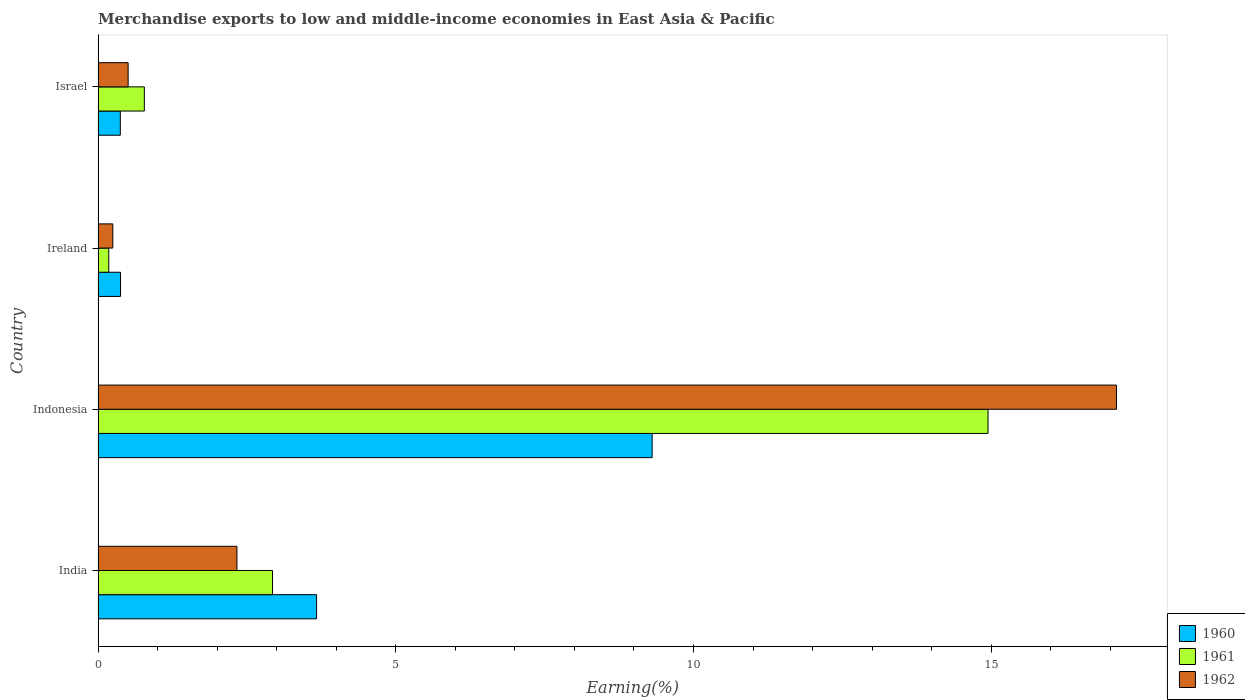Are the number of bars per tick equal to the number of legend labels?
Offer a very short reply. Yes. What is the label of the 2nd group of bars from the top?
Make the answer very short. Ireland. What is the percentage of amount earned from merchandise exports in 1962 in Ireland?
Provide a short and direct response. 0.25. Across all countries, what is the maximum percentage of amount earned from merchandise exports in 1961?
Make the answer very short. 14.95. Across all countries, what is the minimum percentage of amount earned from merchandise exports in 1961?
Provide a short and direct response. 0.18. In which country was the percentage of amount earned from merchandise exports in 1960 maximum?
Ensure brevity in your answer.  Indonesia. What is the total percentage of amount earned from merchandise exports in 1962 in the graph?
Your response must be concise. 20.19. What is the difference between the percentage of amount earned from merchandise exports in 1961 in Indonesia and that in Ireland?
Your answer should be compact. 14.77. What is the difference between the percentage of amount earned from merchandise exports in 1960 in Israel and the percentage of amount earned from merchandise exports in 1961 in India?
Your answer should be compact. -2.56. What is the average percentage of amount earned from merchandise exports in 1960 per country?
Offer a very short reply. 3.43. What is the difference between the percentage of amount earned from merchandise exports in 1962 and percentage of amount earned from merchandise exports in 1961 in India?
Provide a succinct answer. -0.6. In how many countries, is the percentage of amount earned from merchandise exports in 1961 greater than 11 %?
Your answer should be very brief. 1. What is the ratio of the percentage of amount earned from merchandise exports in 1960 in India to that in Israel?
Offer a very short reply. 9.84. Is the difference between the percentage of amount earned from merchandise exports in 1962 in India and Israel greater than the difference between the percentage of amount earned from merchandise exports in 1961 in India and Israel?
Make the answer very short. No. What is the difference between the highest and the second highest percentage of amount earned from merchandise exports in 1961?
Offer a terse response. 12.02. What is the difference between the highest and the lowest percentage of amount earned from merchandise exports in 1960?
Make the answer very short. 8.93. Is it the case that in every country, the sum of the percentage of amount earned from merchandise exports in 1962 and percentage of amount earned from merchandise exports in 1960 is greater than the percentage of amount earned from merchandise exports in 1961?
Your answer should be very brief. Yes. How many bars are there?
Provide a succinct answer. 12. Are all the bars in the graph horizontal?
Provide a succinct answer. Yes. How many countries are there in the graph?
Your response must be concise. 4. Does the graph contain any zero values?
Provide a short and direct response. No. Does the graph contain grids?
Provide a short and direct response. No. Where does the legend appear in the graph?
Your response must be concise. Bottom right. How many legend labels are there?
Your answer should be very brief. 3. What is the title of the graph?
Provide a short and direct response. Merchandise exports to low and middle-income economies in East Asia & Pacific. Does "2009" appear as one of the legend labels in the graph?
Your answer should be compact. No. What is the label or title of the X-axis?
Your response must be concise. Earning(%). What is the Earning(%) of 1960 in India?
Offer a terse response. 3.67. What is the Earning(%) of 1961 in India?
Your answer should be very brief. 2.93. What is the Earning(%) of 1962 in India?
Offer a terse response. 2.33. What is the Earning(%) in 1960 in Indonesia?
Offer a very short reply. 9.31. What is the Earning(%) in 1961 in Indonesia?
Provide a succinct answer. 14.95. What is the Earning(%) in 1962 in Indonesia?
Keep it short and to the point. 17.11. What is the Earning(%) in 1960 in Ireland?
Provide a succinct answer. 0.38. What is the Earning(%) of 1961 in Ireland?
Your response must be concise. 0.18. What is the Earning(%) in 1962 in Ireland?
Your answer should be compact. 0.25. What is the Earning(%) of 1960 in Israel?
Keep it short and to the point. 0.37. What is the Earning(%) in 1961 in Israel?
Provide a short and direct response. 0.78. What is the Earning(%) in 1962 in Israel?
Your answer should be compact. 0.5. Across all countries, what is the maximum Earning(%) in 1960?
Give a very brief answer. 9.31. Across all countries, what is the maximum Earning(%) of 1961?
Make the answer very short. 14.95. Across all countries, what is the maximum Earning(%) of 1962?
Your answer should be compact. 17.11. Across all countries, what is the minimum Earning(%) in 1960?
Give a very brief answer. 0.37. Across all countries, what is the minimum Earning(%) of 1961?
Offer a terse response. 0.18. Across all countries, what is the minimum Earning(%) of 1962?
Offer a very short reply. 0.25. What is the total Earning(%) of 1960 in the graph?
Offer a terse response. 13.72. What is the total Earning(%) of 1961 in the graph?
Keep it short and to the point. 18.83. What is the total Earning(%) of 1962 in the graph?
Offer a very short reply. 20.19. What is the difference between the Earning(%) of 1960 in India and that in Indonesia?
Offer a terse response. -5.64. What is the difference between the Earning(%) in 1961 in India and that in Indonesia?
Give a very brief answer. -12.02. What is the difference between the Earning(%) of 1962 in India and that in Indonesia?
Give a very brief answer. -14.77. What is the difference between the Earning(%) of 1960 in India and that in Ireland?
Make the answer very short. 3.29. What is the difference between the Earning(%) in 1961 in India and that in Ireland?
Offer a very short reply. 2.75. What is the difference between the Earning(%) of 1962 in India and that in Ireland?
Offer a terse response. 2.09. What is the difference between the Earning(%) in 1960 in India and that in Israel?
Offer a very short reply. 3.3. What is the difference between the Earning(%) in 1961 in India and that in Israel?
Keep it short and to the point. 2.15. What is the difference between the Earning(%) in 1962 in India and that in Israel?
Provide a short and direct response. 1.83. What is the difference between the Earning(%) of 1960 in Indonesia and that in Ireland?
Give a very brief answer. 8.93. What is the difference between the Earning(%) of 1961 in Indonesia and that in Ireland?
Give a very brief answer. 14.77. What is the difference between the Earning(%) in 1962 in Indonesia and that in Ireland?
Offer a terse response. 16.86. What is the difference between the Earning(%) in 1960 in Indonesia and that in Israel?
Your answer should be compact. 8.93. What is the difference between the Earning(%) of 1961 in Indonesia and that in Israel?
Your answer should be compact. 14.17. What is the difference between the Earning(%) of 1962 in Indonesia and that in Israel?
Your answer should be compact. 16.6. What is the difference between the Earning(%) of 1960 in Ireland and that in Israel?
Offer a terse response. 0. What is the difference between the Earning(%) of 1961 in Ireland and that in Israel?
Offer a terse response. -0.6. What is the difference between the Earning(%) in 1962 in Ireland and that in Israel?
Your answer should be very brief. -0.26. What is the difference between the Earning(%) in 1960 in India and the Earning(%) in 1961 in Indonesia?
Your response must be concise. -11.28. What is the difference between the Earning(%) of 1960 in India and the Earning(%) of 1962 in Indonesia?
Make the answer very short. -13.44. What is the difference between the Earning(%) in 1961 in India and the Earning(%) in 1962 in Indonesia?
Provide a succinct answer. -14.18. What is the difference between the Earning(%) of 1960 in India and the Earning(%) of 1961 in Ireland?
Give a very brief answer. 3.49. What is the difference between the Earning(%) in 1960 in India and the Earning(%) in 1962 in Ireland?
Provide a short and direct response. 3.42. What is the difference between the Earning(%) in 1961 in India and the Earning(%) in 1962 in Ireland?
Ensure brevity in your answer.  2.68. What is the difference between the Earning(%) in 1960 in India and the Earning(%) in 1961 in Israel?
Offer a very short reply. 2.89. What is the difference between the Earning(%) of 1960 in India and the Earning(%) of 1962 in Israel?
Offer a terse response. 3.17. What is the difference between the Earning(%) of 1961 in India and the Earning(%) of 1962 in Israel?
Provide a short and direct response. 2.43. What is the difference between the Earning(%) of 1960 in Indonesia and the Earning(%) of 1961 in Ireland?
Make the answer very short. 9.13. What is the difference between the Earning(%) of 1960 in Indonesia and the Earning(%) of 1962 in Ireland?
Keep it short and to the point. 9.06. What is the difference between the Earning(%) of 1961 in Indonesia and the Earning(%) of 1962 in Ireland?
Your answer should be very brief. 14.7. What is the difference between the Earning(%) in 1960 in Indonesia and the Earning(%) in 1961 in Israel?
Provide a short and direct response. 8.53. What is the difference between the Earning(%) of 1960 in Indonesia and the Earning(%) of 1962 in Israel?
Your answer should be compact. 8.8. What is the difference between the Earning(%) in 1961 in Indonesia and the Earning(%) in 1962 in Israel?
Keep it short and to the point. 14.44. What is the difference between the Earning(%) of 1960 in Ireland and the Earning(%) of 1961 in Israel?
Keep it short and to the point. -0.4. What is the difference between the Earning(%) of 1960 in Ireland and the Earning(%) of 1962 in Israel?
Give a very brief answer. -0.13. What is the difference between the Earning(%) in 1961 in Ireland and the Earning(%) in 1962 in Israel?
Provide a short and direct response. -0.33. What is the average Earning(%) in 1960 per country?
Your answer should be very brief. 3.43. What is the average Earning(%) in 1961 per country?
Make the answer very short. 4.71. What is the average Earning(%) of 1962 per country?
Offer a very short reply. 5.05. What is the difference between the Earning(%) of 1960 and Earning(%) of 1961 in India?
Provide a succinct answer. 0.74. What is the difference between the Earning(%) in 1960 and Earning(%) in 1962 in India?
Ensure brevity in your answer.  1.34. What is the difference between the Earning(%) in 1961 and Earning(%) in 1962 in India?
Your answer should be compact. 0.6. What is the difference between the Earning(%) in 1960 and Earning(%) in 1961 in Indonesia?
Give a very brief answer. -5.64. What is the difference between the Earning(%) in 1960 and Earning(%) in 1962 in Indonesia?
Make the answer very short. -7.8. What is the difference between the Earning(%) in 1961 and Earning(%) in 1962 in Indonesia?
Your response must be concise. -2.16. What is the difference between the Earning(%) of 1960 and Earning(%) of 1961 in Ireland?
Your answer should be very brief. 0.2. What is the difference between the Earning(%) in 1960 and Earning(%) in 1962 in Ireland?
Your answer should be very brief. 0.13. What is the difference between the Earning(%) of 1961 and Earning(%) of 1962 in Ireland?
Your response must be concise. -0.07. What is the difference between the Earning(%) in 1960 and Earning(%) in 1961 in Israel?
Your answer should be very brief. -0.4. What is the difference between the Earning(%) of 1960 and Earning(%) of 1962 in Israel?
Your answer should be compact. -0.13. What is the difference between the Earning(%) of 1961 and Earning(%) of 1962 in Israel?
Keep it short and to the point. 0.27. What is the ratio of the Earning(%) in 1960 in India to that in Indonesia?
Your answer should be compact. 0.39. What is the ratio of the Earning(%) in 1961 in India to that in Indonesia?
Give a very brief answer. 0.2. What is the ratio of the Earning(%) in 1962 in India to that in Indonesia?
Offer a very short reply. 0.14. What is the ratio of the Earning(%) of 1960 in India to that in Ireland?
Keep it short and to the point. 9.75. What is the ratio of the Earning(%) in 1961 in India to that in Ireland?
Provide a short and direct response. 16.41. What is the ratio of the Earning(%) in 1962 in India to that in Ireland?
Keep it short and to the point. 9.46. What is the ratio of the Earning(%) of 1960 in India to that in Israel?
Give a very brief answer. 9.84. What is the ratio of the Earning(%) of 1961 in India to that in Israel?
Give a very brief answer. 3.77. What is the ratio of the Earning(%) in 1962 in India to that in Israel?
Offer a terse response. 4.63. What is the ratio of the Earning(%) in 1960 in Indonesia to that in Ireland?
Provide a succinct answer. 24.74. What is the ratio of the Earning(%) in 1961 in Indonesia to that in Ireland?
Your answer should be compact. 83.74. What is the ratio of the Earning(%) in 1962 in Indonesia to that in Ireland?
Your response must be concise. 69.36. What is the ratio of the Earning(%) of 1960 in Indonesia to that in Israel?
Offer a terse response. 24.96. What is the ratio of the Earning(%) of 1961 in Indonesia to that in Israel?
Provide a short and direct response. 19.25. What is the ratio of the Earning(%) in 1962 in Indonesia to that in Israel?
Your response must be concise. 33.94. What is the ratio of the Earning(%) in 1960 in Ireland to that in Israel?
Provide a short and direct response. 1.01. What is the ratio of the Earning(%) of 1961 in Ireland to that in Israel?
Provide a succinct answer. 0.23. What is the ratio of the Earning(%) of 1962 in Ireland to that in Israel?
Your answer should be very brief. 0.49. What is the difference between the highest and the second highest Earning(%) in 1960?
Provide a succinct answer. 5.64. What is the difference between the highest and the second highest Earning(%) in 1961?
Offer a terse response. 12.02. What is the difference between the highest and the second highest Earning(%) of 1962?
Offer a terse response. 14.77. What is the difference between the highest and the lowest Earning(%) in 1960?
Keep it short and to the point. 8.93. What is the difference between the highest and the lowest Earning(%) of 1961?
Provide a short and direct response. 14.77. What is the difference between the highest and the lowest Earning(%) of 1962?
Offer a very short reply. 16.86. 